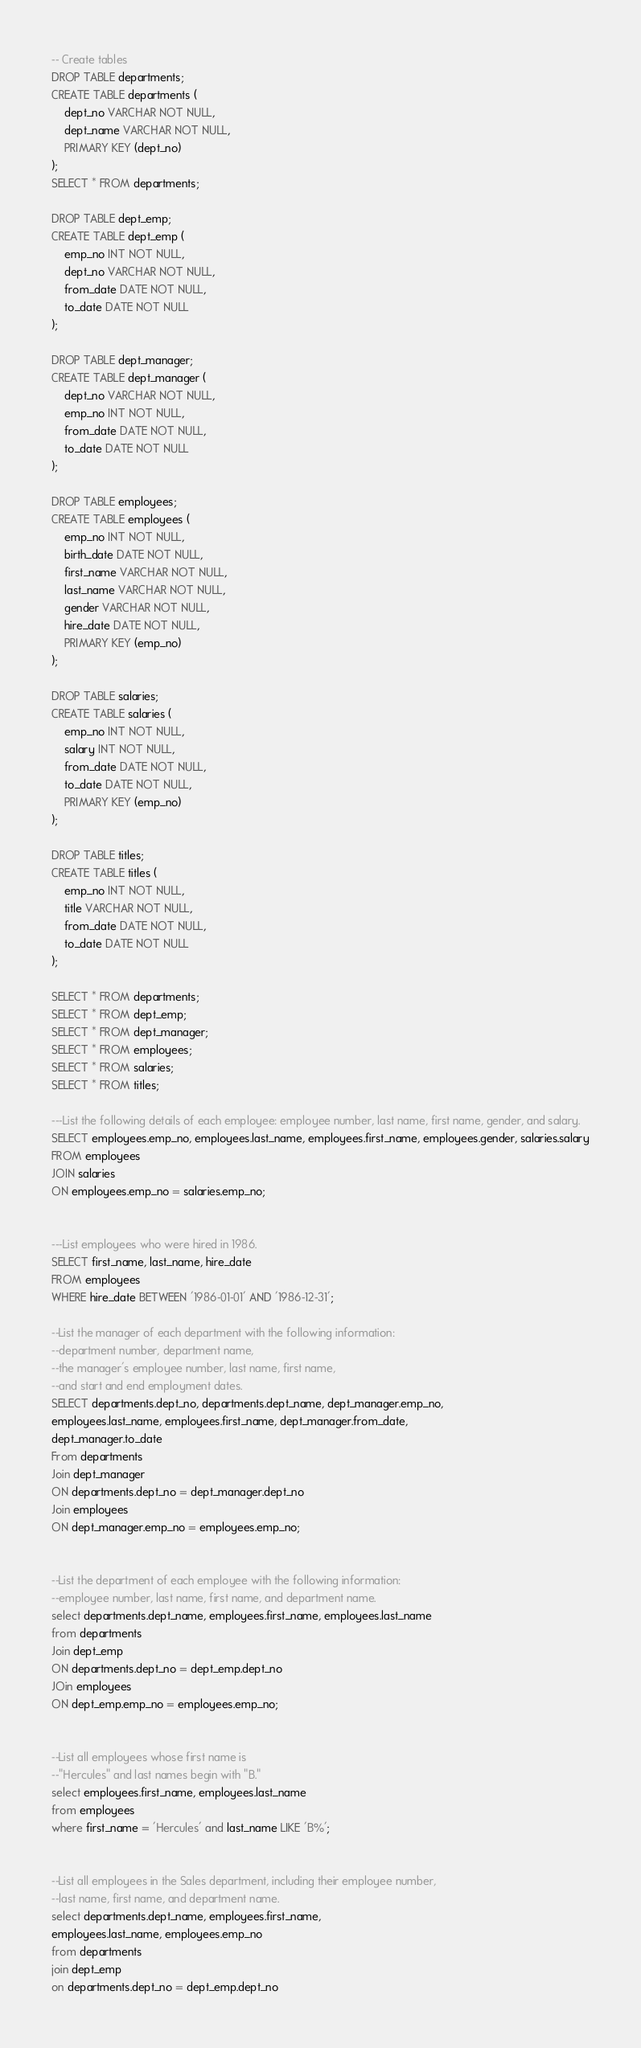<code> <loc_0><loc_0><loc_500><loc_500><_SQL_>-- Create tables
DROP TABLE departments;
CREATE TABLE departments (
	dept_no VARCHAR NOT NULL,
	dept_name VARCHAR NOT NULL,
	PRIMARY KEY (dept_no)
);
SELECT * FROM departments;

DROP TABLE dept_emp;
CREATE TABLE dept_emp (
	emp_no INT NOT NULL,
	dept_no VARCHAR NOT NULL,
	from_date DATE NOT NULL,
	to_date DATE NOT NULL
);

DROP TABLE dept_manager;
CREATE TABLE dept_manager (
	dept_no VARCHAR NOT NULL,
	emp_no INT NOT NULL,
	from_date DATE NOT NULL,
	to_date DATE NOT NULL
);

DROP TABLE employees;
CREATE TABLE employees (
	emp_no INT NOT NULL,
	birth_date DATE NOT NULL,
	first_name VARCHAR NOT NULL,
	last_name VARCHAR NOT NULL,
	gender VARCHAR NOT NULL,
	hire_date DATE NOT NULL,
	PRIMARY KEY (emp_no)
);

DROP TABLE salaries;
CREATE TABLE salaries (
	emp_no INT NOT NULL,
	salary INT NOT NULL,
	from_date DATE NOT NULL,
	to_date DATE NOT NULL,
	PRIMARY KEY (emp_no)
);

DROP TABLE titles;
CREATE TABLE titles (
	emp_no INT NOT NULL,
	title VARCHAR NOT NULL,
	from_date DATE NOT NULL,
	to_date DATE NOT NULL
);

SELECT * FROM departments;
SELECT * FROM dept_emp;
SELECT * FROM dept_manager;
SELECT * FROM employees;
SELECT * FROM salaries;
SELECT * FROM titles;

---List the following details of each employee: employee number, last name, first name, gender, and salary.
SELECT employees.emp_no, employees.last_name, employees.first_name, employees.gender, salaries.salary
FROM employees
JOIN salaries
ON employees.emp_no = salaries.emp_no;


---List employees who were hired in 1986.
SELECT first_name, last_name, hire_date
FROM employees
WHERE hire_date BETWEEN '1986-01-01' AND '1986-12-31';

--List the manager of each department with the following information:
--department number, department name, 
--the manager's employee number, last name, first name, 
--and start and end employment dates.
SELECT departments.dept_no, departments.dept_name, dept_manager.emp_no, 
employees.last_name, employees.first_name, dept_manager.from_date, 
dept_manager.to_date
From departments
Join dept_manager
ON departments.dept_no = dept_manager.dept_no
Join employees
ON dept_manager.emp_no = employees.emp_no;


--List the department of each employee with the following information: 
--employee number, last name, first name, and department name.
select departments.dept_name, employees.first_name, employees.last_name
from departments
Join dept_emp
ON departments.dept_no = dept_emp.dept_no
JOin employees
ON dept_emp.emp_no = employees.emp_no;


--List all employees whose first name is 
--"Hercules" and last names begin with "B."
select employees.first_name, employees.last_name
from employees
where first_name = 'Hercules' and last_name LIKE 'B%';


--List all employees in the Sales department, including their employee number, 
--last name, first name, and department name.
select departments.dept_name, employees.first_name, 
employees.last_name, employees.emp_no
from departments
join dept_emp
on departments.dept_no = dept_emp.dept_no</code> 